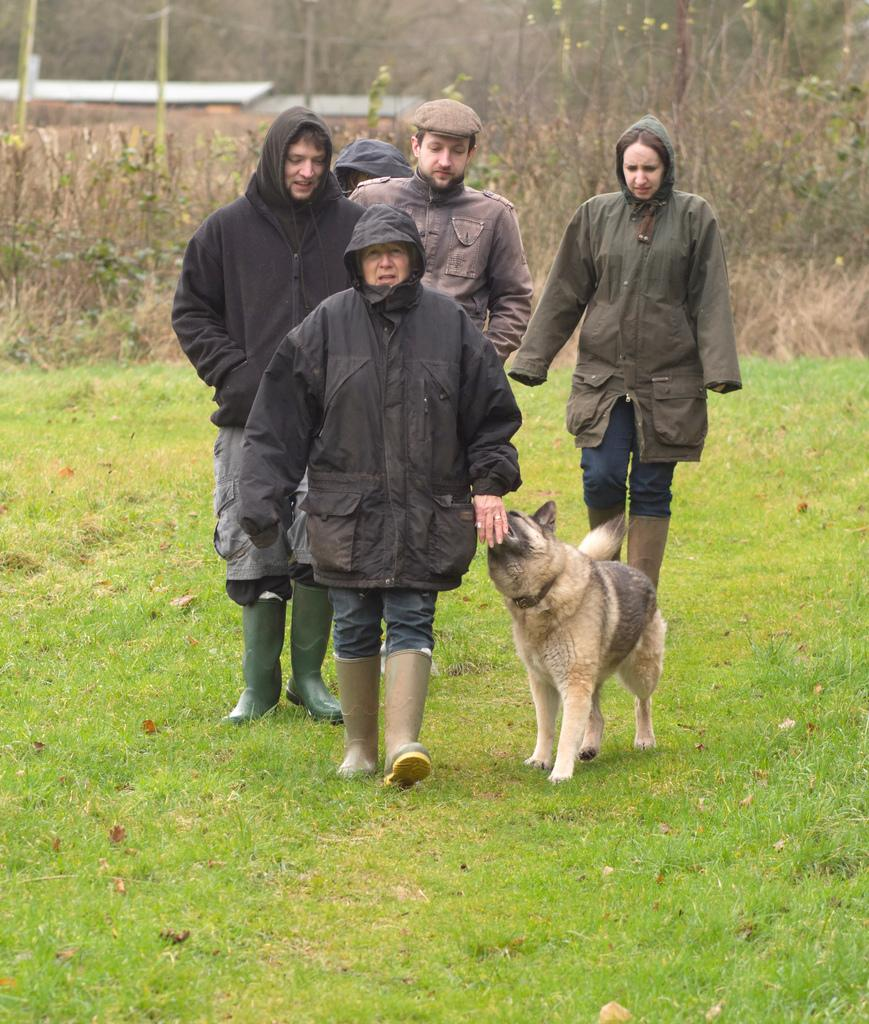How many persons are in the image? There are persons in the image, but the exact number is not specified. What type of animal is present in the image? There is a dog in the image. What can be seen in the background of the image? In the background of the image, there are plants, poles, and other objects. What type of ground surface is visible at the bottom of the image? There is grass at the bottom of the image. What type of bread is being served in the church in the image? There is no church or bread present in the image. 